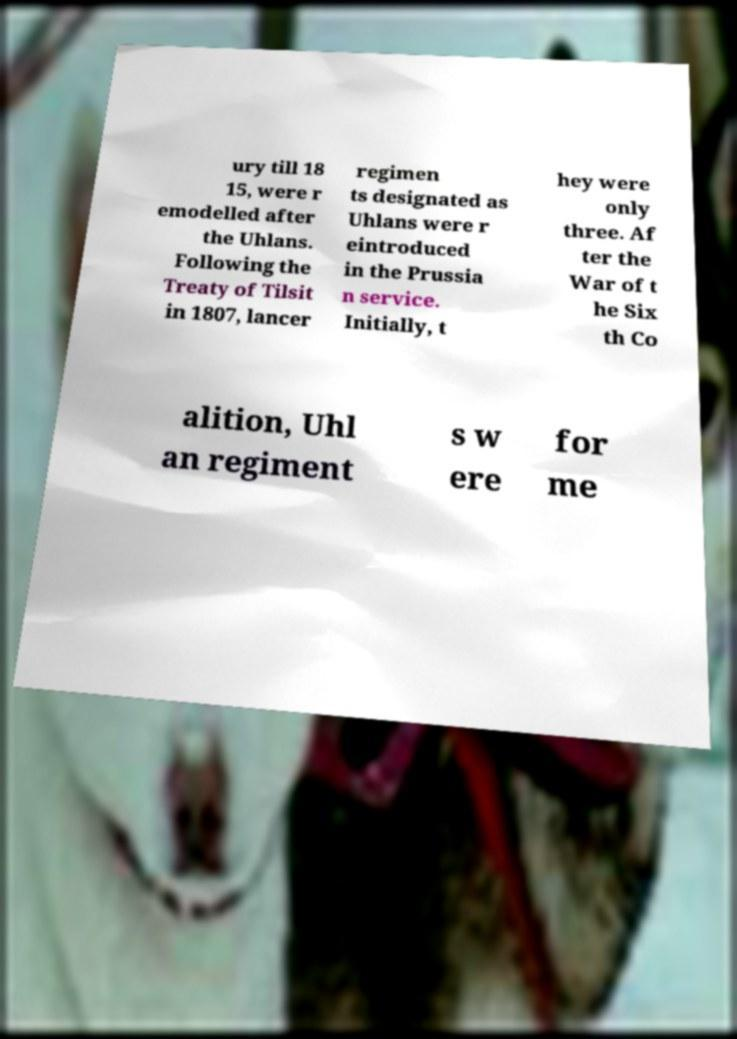What messages or text are displayed in this image? I need them in a readable, typed format. ury till 18 15, were r emodelled after the Uhlans. Following the Treaty of Tilsit in 1807, lancer regimen ts designated as Uhlans were r eintroduced in the Prussia n service. Initially, t hey were only three. Af ter the War of t he Six th Co alition, Uhl an regiment s w ere for me 